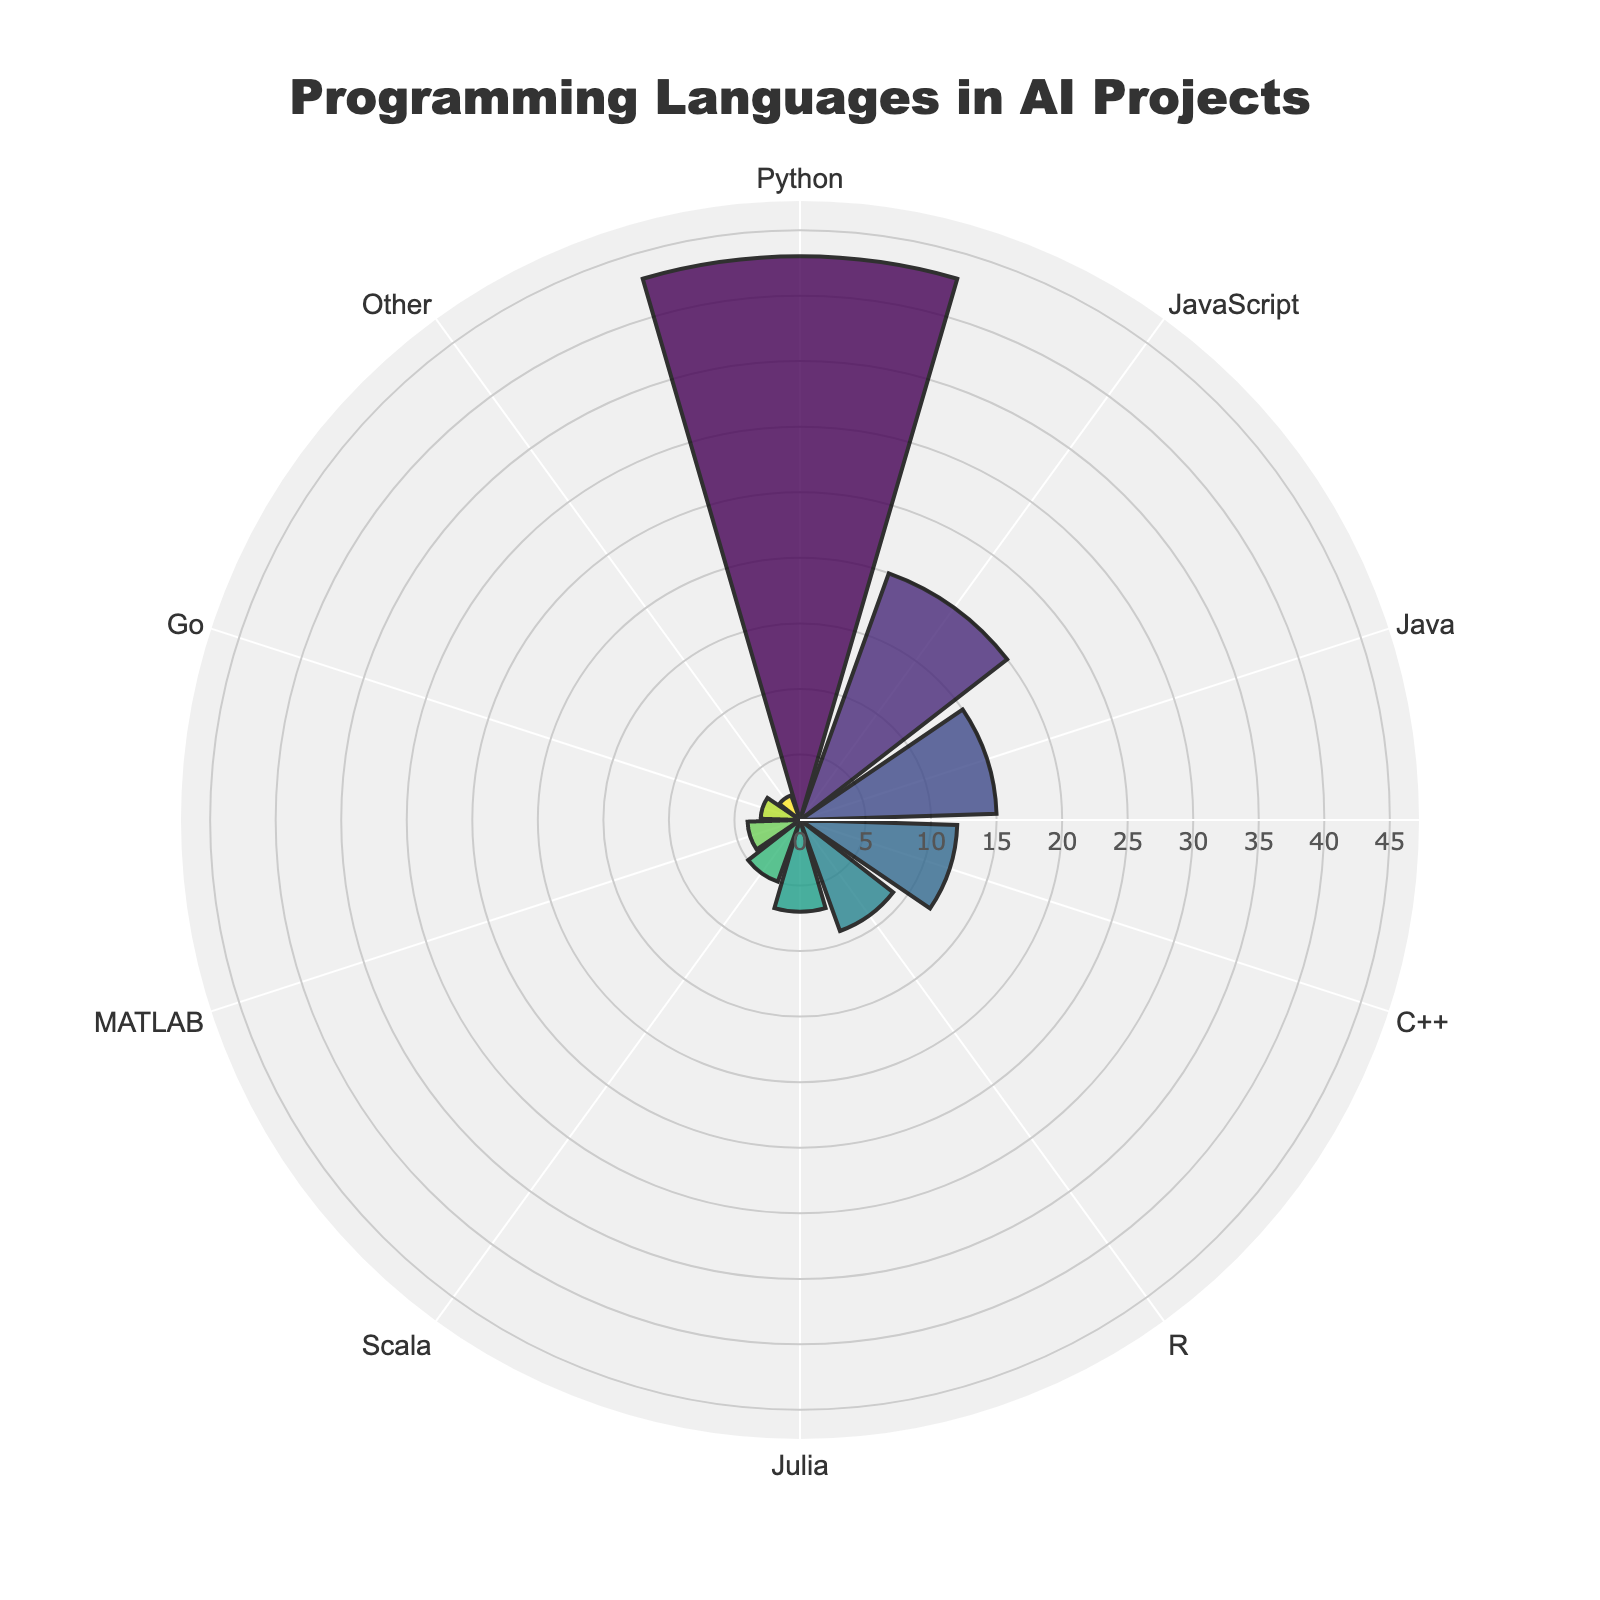Which programming language has the highest number of repositories? The chart shows the number of repositories for each programming language on a radial scale. By looking at the graph, the language with the highest bar is the one with the most repositories.
Answer: Python What is the total number of repositories for C++ and Java combined? To find the total, add the number of repositories for C++ and Java. According to the chart, C++ has 12 repositories and Java has 15 repositories. So, 12 + 15 = 27.
Answer: 27 How many more repositories does Python have compared to R? Python has 43 repositories and R has 9 repositories. Subtract the number of R repositories from the Python repositories: 43 - 9 = 34.
Answer: 34 Which language has fewer repositories: MATLAB or Julia? Compare the heights of the bars for MATLAB and Julia. Julia has 7 repositories and MATLAB has 4, so MATLAB has fewer repositories.
Answer: MATLAB How do the number of repositories for JavaScript and Java compare? JavaScript has 20 repositories and Java has 15. By comparing these values, JavaScript has more repositories.
Answer: JavaScript Is the number of repositories for Go greater than Scala? The chart shows Go has 3 repositories and Scala has 5. By comparing these values, we can see that Go has fewer repositories than Scala.
Answer: No What is the average number of repositories among Python, JavaScript, and Java? The sum of the repositories for Python (43), JavaScript (20), and Java (15) is 78. Dividing by the number of languages (3), the average is 78 / 3 = 26.
Answer: 26 Which languages have fewer than 10 repositories each? From the chart, the languages with fewer than 10 repositories are Julia (7), Scala (5), MATLAB (4), Go (3), and Other (2).
Answer: Julia, Scala, MATLAB, Go, Other If Python has 43 repositories, what fraction of the total does it represent if the total is the sum of all repositories? First, find the total number of repositories by summing them all up: 43 (Python) + 20 (JavaScript) + 15 (Java) + 12 (C++) + 9 (R) + 7 (Julia) + 5 (Scala) + 4 (MATLAB) + 3 (Go) + 2 (Other) = 120. The fraction is 43/120.
Answer: 43/120 